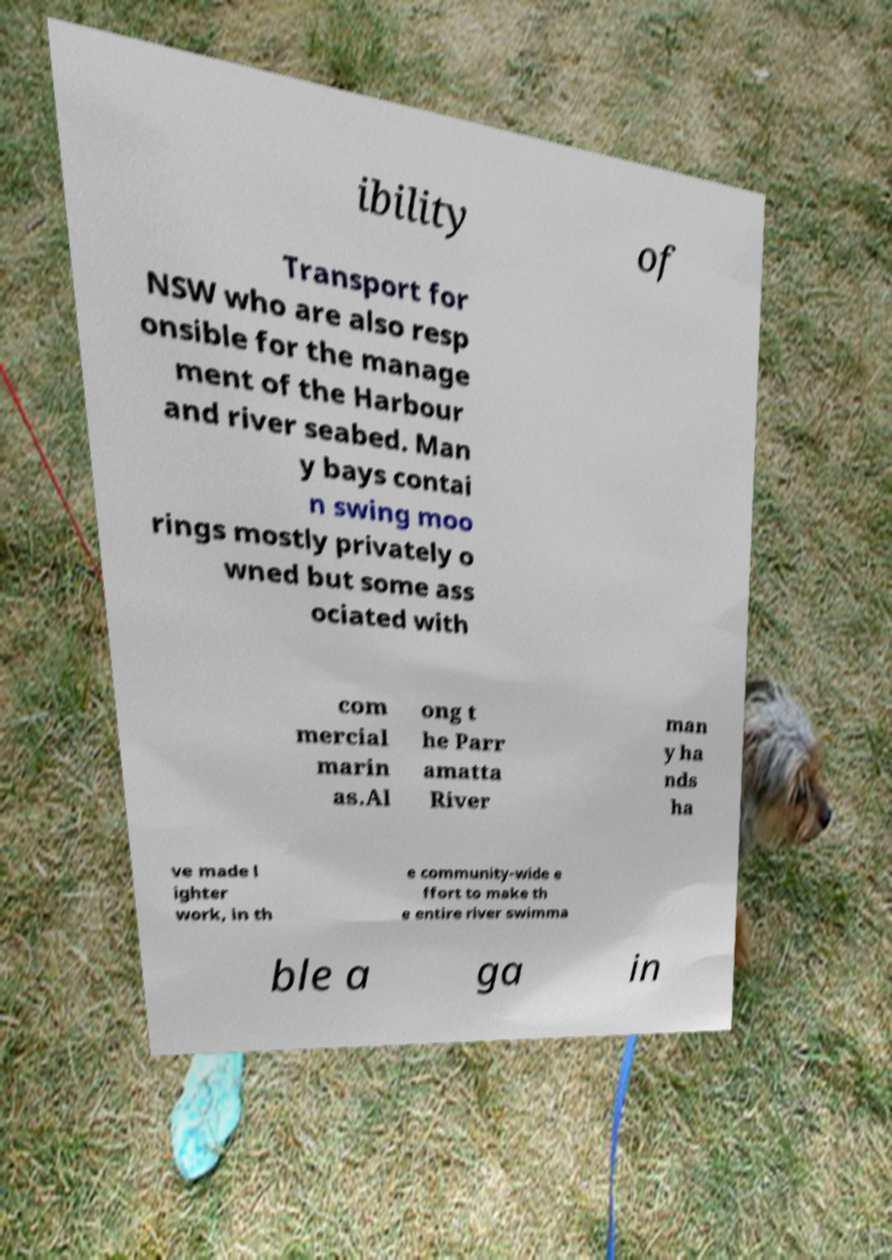I need the written content from this picture converted into text. Can you do that? ibility of Transport for NSW who are also resp onsible for the manage ment of the Harbour and river seabed. Man y bays contai n swing moo rings mostly privately o wned but some ass ociated with com mercial marin as.Al ong t he Parr amatta River man y ha nds ha ve made l ighter work, in th e community-wide e ffort to make th e entire river swimma ble a ga in 